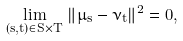<formula> <loc_0><loc_0><loc_500><loc_500>\lim _ { ( s , t ) \in S \times T } \, \| \mu _ { s } - \nu _ { t } \| ^ { 2 } = 0 ,</formula> 